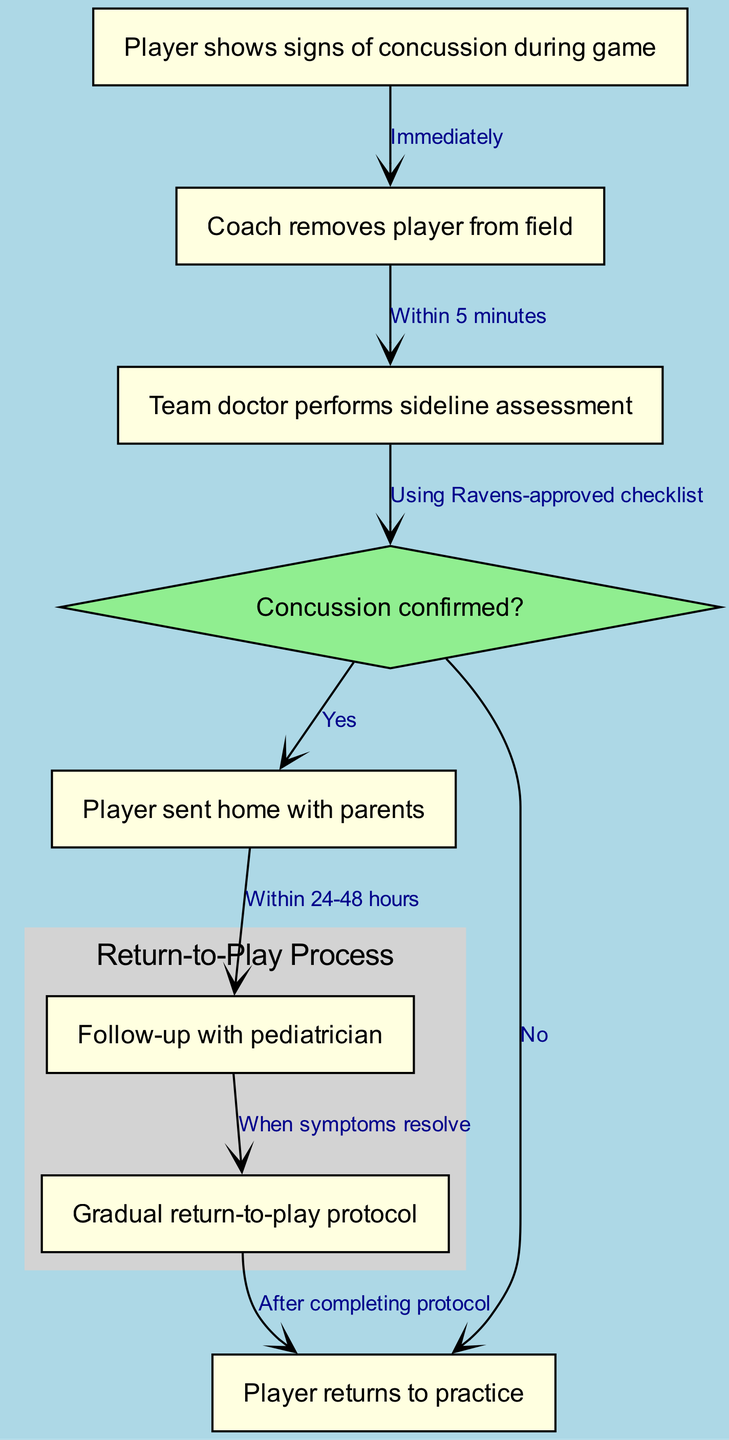What happens immediately when a player shows signs of concussion during a game? According to the diagram, when a player shows signs of concussion, the coach immediately removes the player from the field as the first action.
Answer: Coach removes player from field How long does it take for the coach to remove the player after noticing concussion signs? The diagram specifies that the coach removes the player from the field within 5 minutes of observing the signs of concussion, indicating a prompt response to protect the player's health.
Answer: Within 5 minutes What tool does the team doctor use to assess the player on the sideline? The sideline assessment performed by the team doctor is done using a Ravens-approved checklist, which ensures that recognized and standard measures are in place for evaluating the concussion.
Answer: Ravens-approved checklist What is the outcome if concussion is confirmed? If the team doctor confirms a concussion, the protocol indicates that the player is sent home with their parents for safety and further monitoring, as established in the diagram's flow.
Answer: Player sent home with parents What is the follow-up timeframe with the pediatrician after a concussion? The diagram states that a follow-up with the pediatrician should occur within 24-48 hours after the player is sent home, which is crucial for ongoing care and management of concussion symptoms.
Answer: Within 24-48 hours What must occur before starting the gradual return-to-play protocol? According to the diagram, the player can only begin the gradual return-to-play protocol when symptoms resolve, highlighting the importance of being symptom-free before resuming activities.
Answer: When symptoms resolve After completing the return-to-play protocol, what is the next step for the player? Once the player has successfully completed the gradual return-to-play protocol, they are allowed to return to practice, marking a significant step in their recovery process as outlined in the diagram.
Answer: Player returns to practice How many nodes are in the diagram? The diagram contains a total of 8 nodes, each representing different steps or decisions regarding the concussion assessment and management for youth football players.
Answer: 8 nodes What unique feature does the diagram include for the decision node? The diagram includes a special styling for the decision node, marked as a diamond shape and filled with light green, which visually distinguishes it from other rectangular nodes for better understanding of decision points.
Answer: Diamond shape 